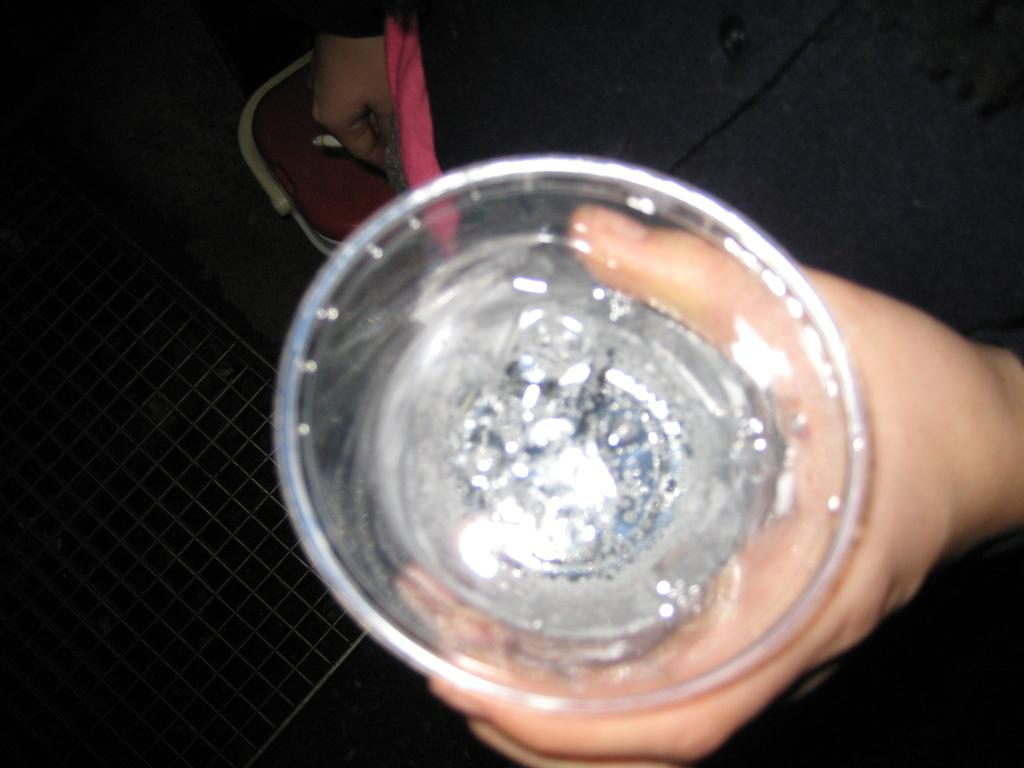What is the person in the image doing with their hands? The person is holding a glass in one hand and a cigarette in the other hand. Can you describe the object beside the person? Unfortunately, the provided facts do not give any information about the object beside the person. What might be in the glass that the person is holding? The contents of the glass are not specified in the provided facts. What type of bun is the person eating in the image? There is no bun present in the image. How much debt does the person have, as shown in the image? There is no information about the person's debt in the image. 